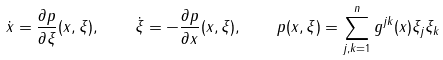<formula> <loc_0><loc_0><loc_500><loc_500>\dot { x } = \frac { \partial p } { \partial \xi } ( x , \xi ) , \quad \dot { \xi } = - \frac { \partial p } { \partial x } ( x , \xi ) , \quad p ( x , \xi ) = \sum _ { j , k = 1 } ^ { n } g ^ { j k } ( x ) \xi _ { j } \xi _ { k }</formula> 